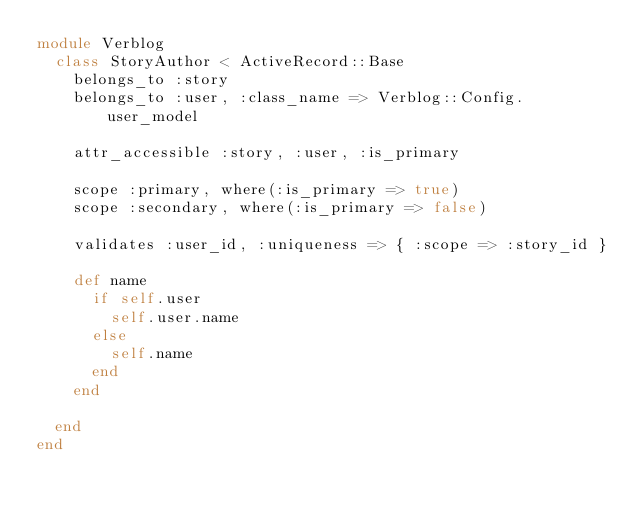Convert code to text. <code><loc_0><loc_0><loc_500><loc_500><_Ruby_>module Verblog
  class StoryAuthor < ActiveRecord::Base
    belongs_to :story
    belongs_to :user, :class_name => Verblog::Config.user_model
    
    attr_accessible :story, :user, :is_primary
    
    scope :primary, where(:is_primary => true)
    scope :secondary, where(:is_primary => false)
    
    validates :user_id, :uniqueness => { :scope => :story_id }
    
    def name
      if self.user
        self.user.name
      else
        self.name
      end
    end  
      
  end
end</code> 